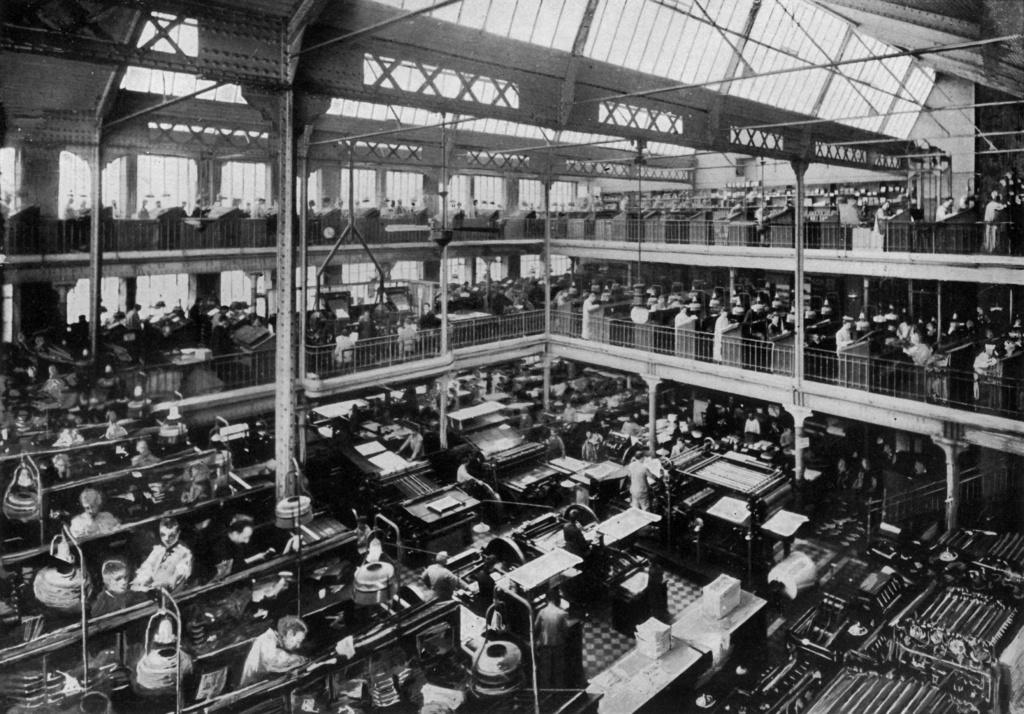What type of location is depicted in the image? The image shows an inner view of a big hall. What can be seen inside the hall? There are machines in the hall. What are the people in the image doing? There are people standing and working on the machines. What month is it in the image? The image does not provide any information about the month or time of year. What type of skin is visible on the machines in the image? The machines in the image do not have skin; they are inanimate objects. 